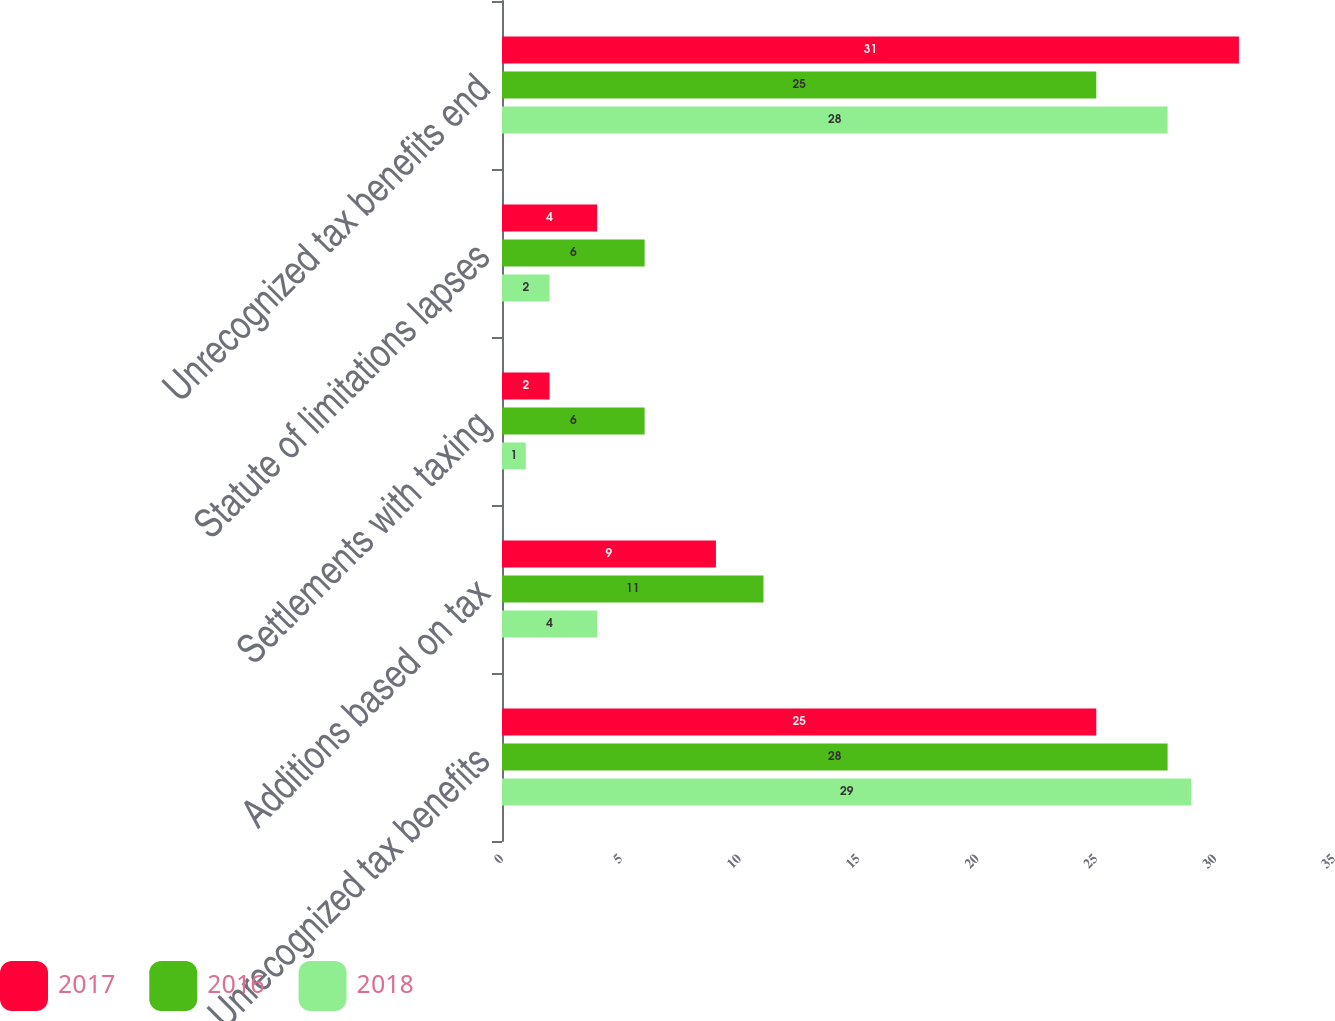Convert chart. <chart><loc_0><loc_0><loc_500><loc_500><stacked_bar_chart><ecel><fcel>Unrecognized tax benefits<fcel>Additions based on tax<fcel>Settlements with taxing<fcel>Statute of limitations lapses<fcel>Unrecognized tax benefits end<nl><fcel>2017<fcel>25<fcel>9<fcel>2<fcel>4<fcel>31<nl><fcel>2016<fcel>28<fcel>11<fcel>6<fcel>6<fcel>25<nl><fcel>2018<fcel>29<fcel>4<fcel>1<fcel>2<fcel>28<nl></chart> 